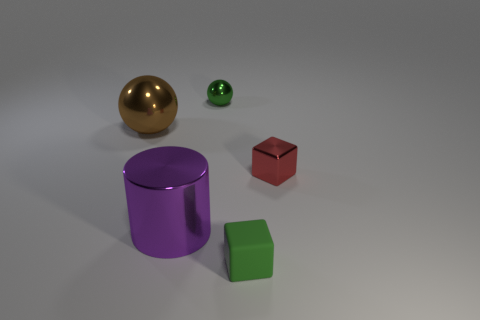Add 1 tiny green metallic spheres. How many objects exist? 6 Subtract all cylinders. How many objects are left? 4 Subtract all big cyan shiny cylinders. Subtract all small green spheres. How many objects are left? 4 Add 3 big purple cylinders. How many big purple cylinders are left? 4 Add 5 red metallic cylinders. How many red metallic cylinders exist? 5 Subtract 0 cyan blocks. How many objects are left? 5 